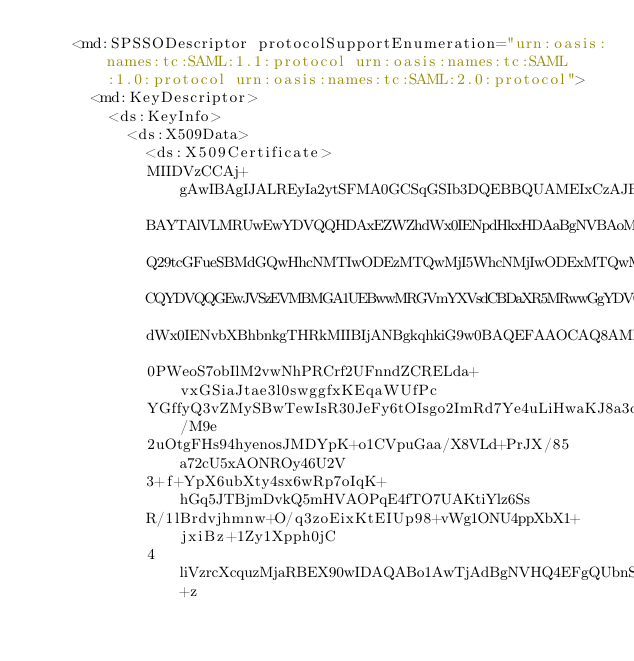<code> <loc_0><loc_0><loc_500><loc_500><_XML_>    <md:SPSSODescriptor protocolSupportEnumeration="urn:oasis:names:tc:SAML:1.1:protocol urn:oasis:names:tc:SAML:1.0:protocol urn:oasis:names:tc:SAML:2.0:protocol">
      <md:KeyDescriptor>
        <ds:KeyInfo>
          <ds:X509Data>
            <ds:X509Certificate>
						MIIDVzCCAj+gAwIBAgIJALREyIa2ytSFMA0GCSqGSIb3DQEBBQUAMEIxCzAJBgNV
						BAYTAlVLMRUwEwYDVQQHDAxEZWZhdWx0IENpdHkxHDAaBgNVBAoME0RlZmF1bHQg
						Q29tcGFueSBMdGQwHhcNMTIwODEzMTQwMjI5WhcNMjIwODExMTQwMjI5WjBCMQsw
						CQYDVQQGEwJVSzEVMBMGA1UEBwwMRGVmYXVsdCBDaXR5MRwwGgYDVQQKDBNEZWZh
						dWx0IENvbXBhbnkgTHRkMIIBIjANBgkqhkiG9w0BAQEFAAOCAQ8AMIIBCgKCAQEA
						0PWeoS7obIlM2vwNhPRCrf2UFnndZCRELda+vxGSiaJtae3l0swggfxKEqaWUfPc
						YGffyQ3vZMySBwTewIsR30JeFy6tOIsgo2ImRd7Ye4uLiHwaKJ8a3deGD8qR/M9e
						2uOtgFHs94hyenosJMDYpK+o1CVpuGaa/X8VLd+PrJX/85a72cU5xAONROy46U2V
						3+f+YpX6ubXty4sx6wRp7oIqK+hGq5JTBjmDvkQ5mHVAOPqE4fTO7UAKtiYlz6Ss
						R/1lBrdvjhmnw+O/q3zoEixKtEIUp98+vWg1ONU4ppXbX1+jxiBz+1Zy1Xpph0jC
						4liVzrcXcquzMjaRBEX90wIDAQABo1AwTjAdBgNVHQ4EFgQUbnSWVvCHIkkjMS+z</code> 